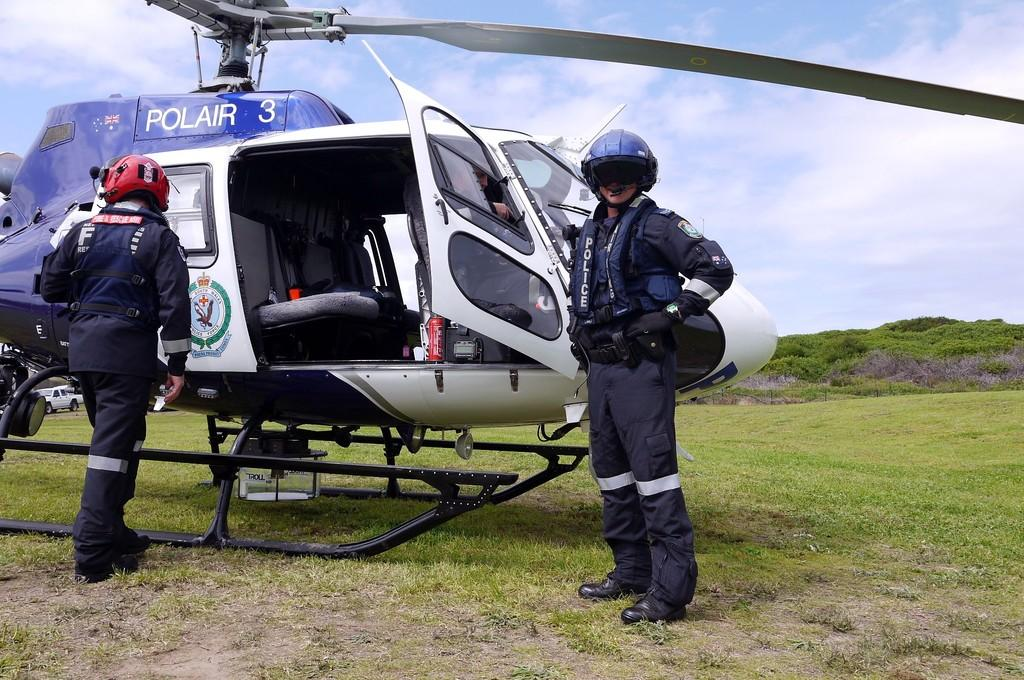What is the main subject of the image? The main subject of the image is an aircraft. How many people are present in the image? Two people are standing in the image. What are the people wearing on their heads? The people are wearing helmets. What type of vegetation can be seen in the image? There are trees in the image. What is the color of the grass in the image? Green grass is visible in the image. What is the color of the sky in the image? The sky is blue and white in color. Where is the bell located in the image? There is no bell present in the image. What type of fuel is being used by the aircraft in the image? The image does not provide information about the type of fuel being used by the aircraft. 